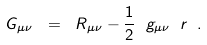Convert formula to latex. <formula><loc_0><loc_0><loc_500><loc_500>G _ { \mu \nu } \ = \ R _ { \mu \nu } - \frac { 1 } { 2 } \ g _ { \mu \nu } \ r \ .</formula> 